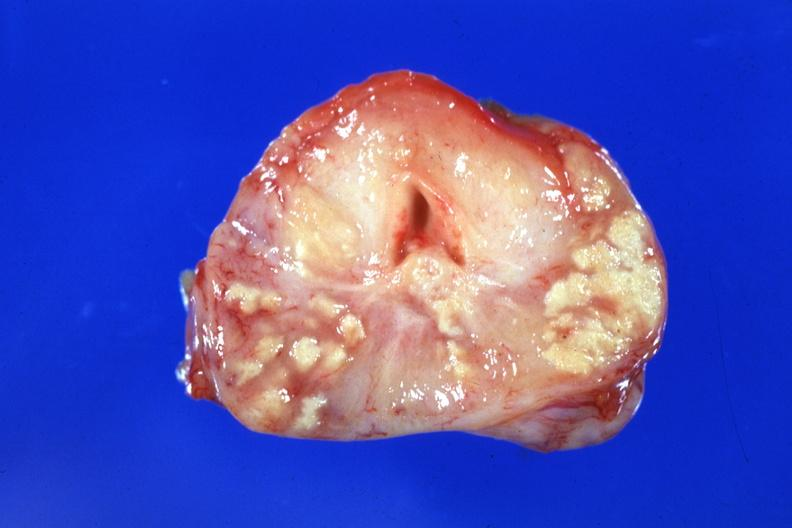what does this image show?
Answer the question using a single word or phrase. Large caseous lesions easily seen excellent example 